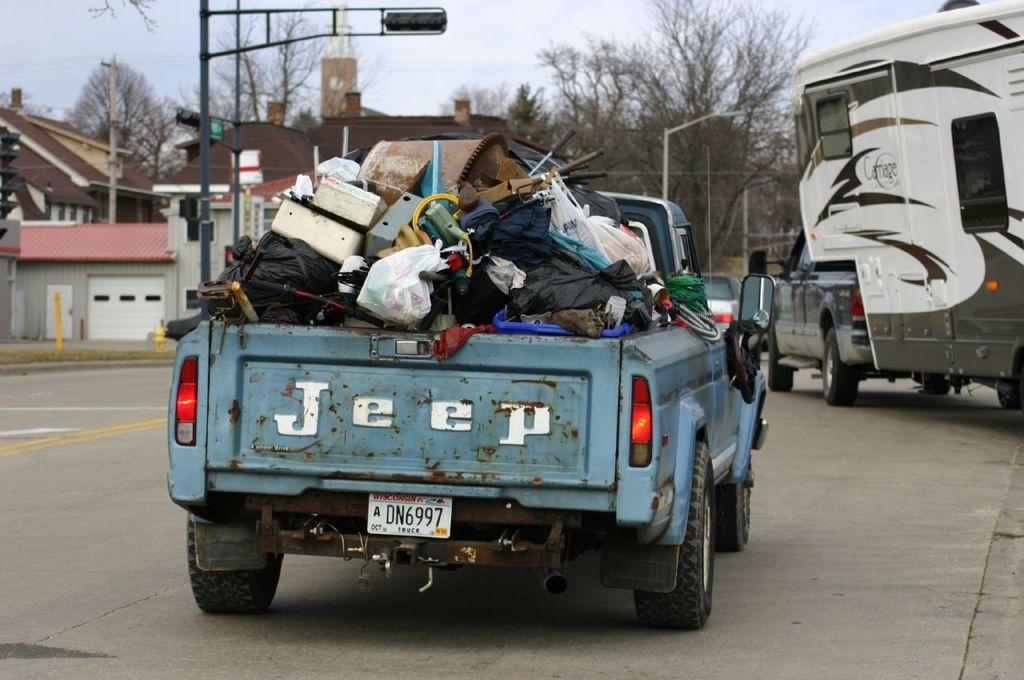In one or two sentences, can you explain what this image depicts? In the picture we can see a road on it, we can see a jeep with full of scrap and in front of the jeep we can see another vehicle and besides the vehicle we can see some poles with lights and houses and in the background we can see trees and sky. 